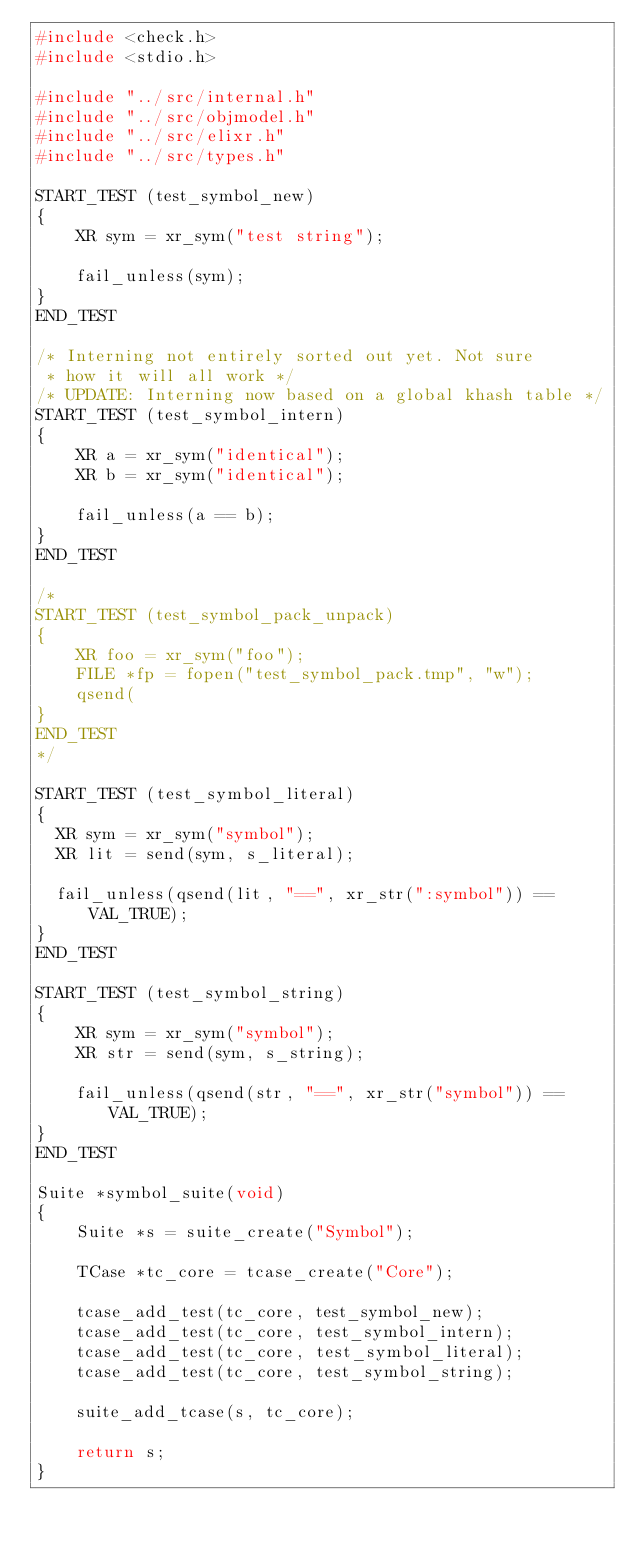Convert code to text. <code><loc_0><loc_0><loc_500><loc_500><_C_>#include <check.h>
#include <stdio.h>

#include "../src/internal.h"
#include "../src/objmodel.h"
#include "../src/elixr.h"
#include "../src/types.h"

START_TEST (test_symbol_new)
{
    XR sym = xr_sym("test string");

    fail_unless(sym);
}
END_TEST

/* Interning not entirely sorted out yet. Not sure
 * how it will all work */
/* UPDATE: Interning now based on a global khash table */
START_TEST (test_symbol_intern)
{
    XR a = xr_sym("identical");
    XR b = xr_sym("identical");

    fail_unless(a == b);
}
END_TEST

/*
START_TEST (test_symbol_pack_unpack)
{
    XR foo = xr_sym("foo");
    FILE *fp = fopen("test_symbol_pack.tmp", "w");
    qsend(
}
END_TEST
*/

START_TEST (test_symbol_literal)
{
	XR sym = xr_sym("symbol");
	XR lit = send(sym, s_literal);

	fail_unless(qsend(lit, "==", xr_str(":symbol")) == VAL_TRUE);
}
END_TEST

START_TEST (test_symbol_string)
{
    XR sym = xr_sym("symbol");
    XR str = send(sym, s_string);

    fail_unless(qsend(str, "==", xr_str("symbol")) == VAL_TRUE);
}
END_TEST

Suite *symbol_suite(void)
{
    Suite *s = suite_create("Symbol");

    TCase *tc_core = tcase_create("Core");
    
    tcase_add_test(tc_core, test_symbol_new);
    tcase_add_test(tc_core, test_symbol_intern);
    tcase_add_test(tc_core, test_symbol_literal);
    tcase_add_test(tc_core, test_symbol_string);

    suite_add_tcase(s, tc_core);

    return s;
}
</code> 